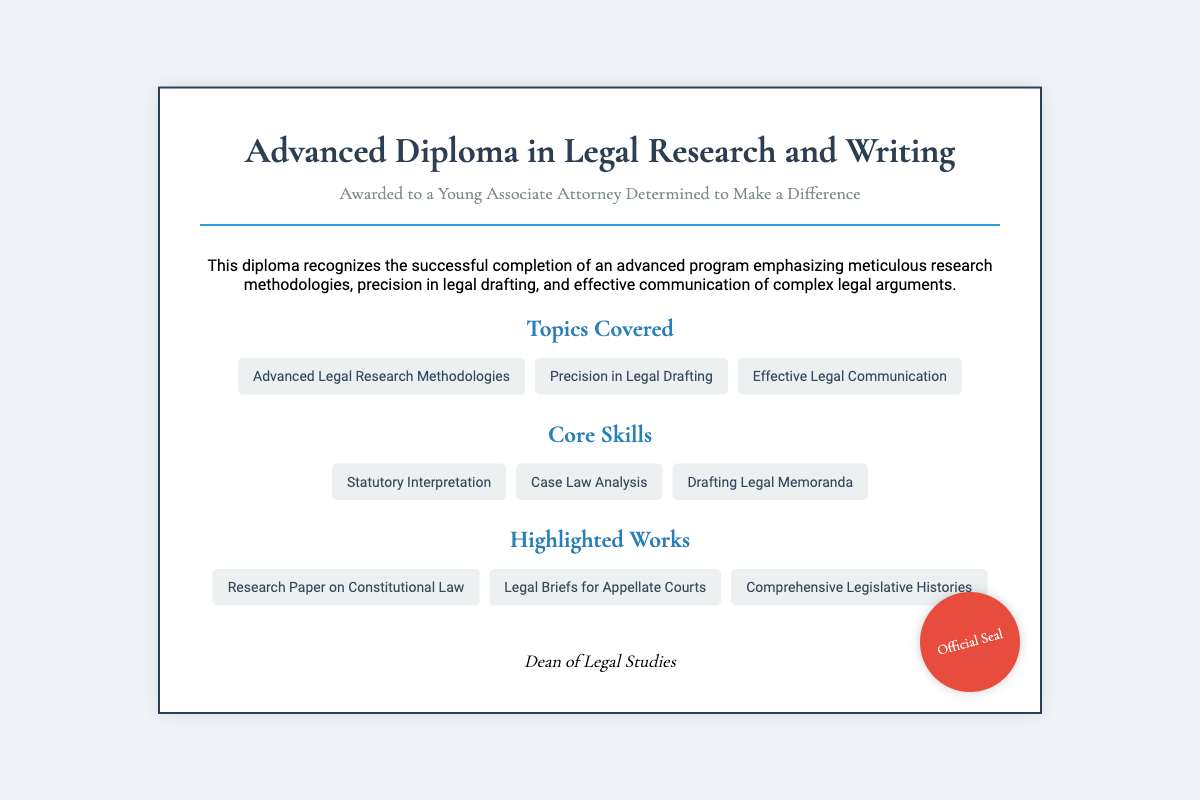What is the title of the diploma? The title of the diploma is presented prominently at the top of the document.
Answer: Advanced Diploma in Legal Research and Writing Who is the diploma awarded to? The document specifies the recipient in the subtitle section.
Answer: A Young Associate Attorney Determined to Make a Difference What are the topics covered in the program? The document lists several topics under the "Topics Covered" section.
Answer: Advanced Legal Research Methodologies What core skill involves analyzing existing legal precedents? The core skills section highlights specific skills that are essential in legal research and writing.
Answer: Case Law Analysis Who signed the diploma? The document indicates the signatory at the bottom, providing credentials.
Answer: Dean of Legal Studies What type of document is this? The structure and content define what type of recognition the document represents.
Answer: Diploma What color are the headings in the document? The document describes the color used for the headings in multiple sections.
Answer: Blue How many highlighted works are listed? The number of items provided in the "Highlighted Works" section reflects the achievements.
Answer: Three 